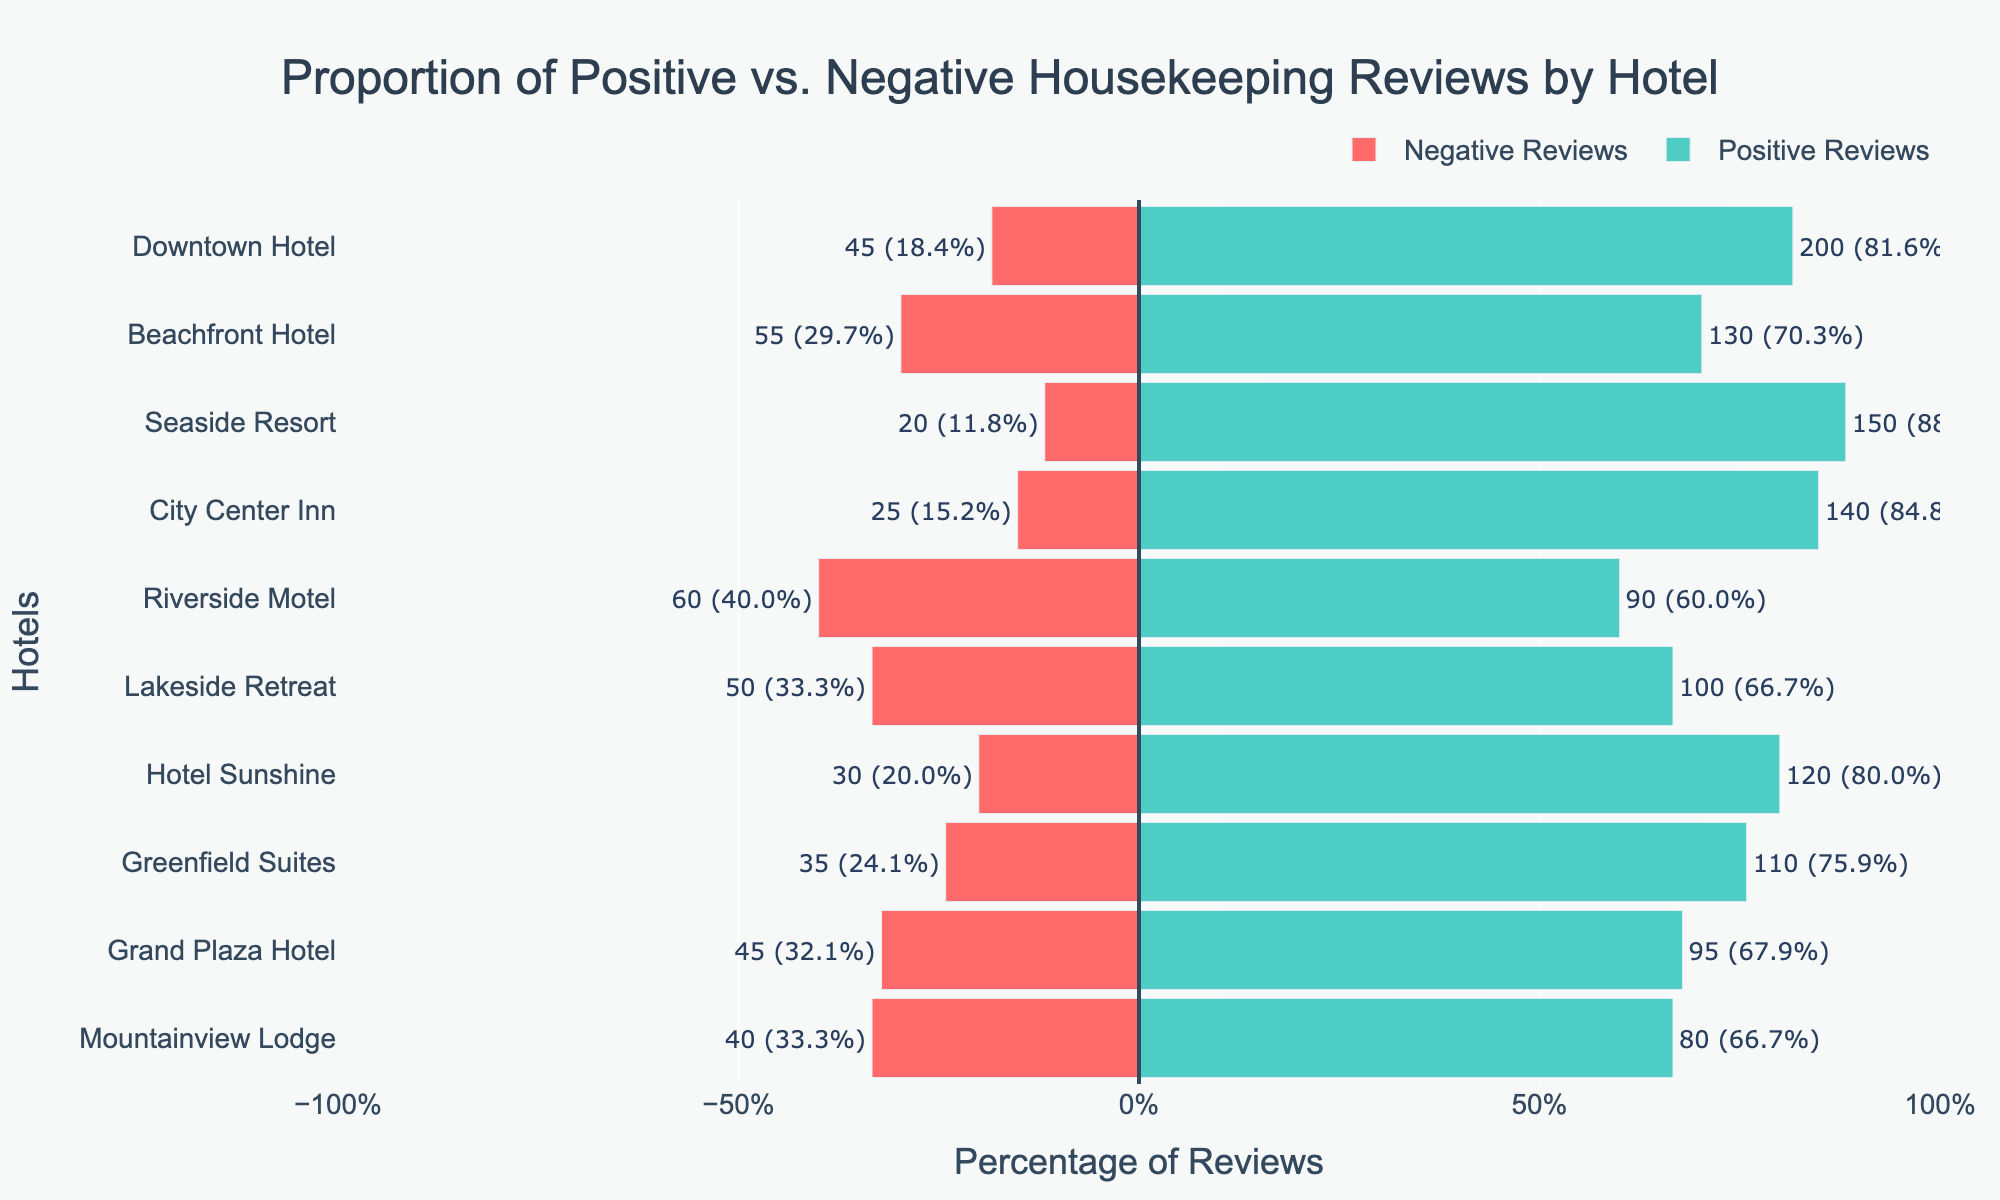What percentage of reviews for Hotel Sunshine are positive? To find the percentage of positive reviews for Hotel Sunshine, we refer to the length of the green bar representing positive reviews. The chart shows that Hotel Sunshine has around 80% positive reviews.
Answer: 80% Which hotel has the highest proportion of negative reviews? We compare the lengths of the red bars representing negative reviews. Riverside Motel has the longest red bar, indicating it has the highest proportion of negative reviews, around 40%.
Answer: Riverside Motel Compare the positive review percentages of City Center Inn and Downtown Hotel. Which one is higher? We look at the lengths of the green bars for both hotels. Downtown Hotel's positive review percentage is higher than City Center Inn's.
Answer: Downtown Hotel What is the difference in the number of positive reviews between Lakeside Retreat and Greenfield Suites? We subtract the number of positive reviews for Lakeside Retreat (100) from Greenfield Suites (110). The difference is 10.
Answer: 10 How many total reviews did Mountainview Lodge receive? Sum the positive and negative reviews for Mountainview Lodge. The hotel has 80 positive and 40 negative reviews, so the total is 120.
Answer: 120 Which hotel has the smallest proportion of positive reviews? We identify the hotel with the shortest green bar representing positive reviews. Riverside Motel has the smallest proportion of positive reviews at around 60%.
Answer: Riverside Motel Are there any hotels where the proportion of negative reviews is less than 20%? We look for hotels with a very short red bar. Seaside Resort has about 15% negative reviews, which is less than 20%.
Answer: Seaside Resort What is the combined percentage of positive reviews for Beachfront Hotel and Seaside Resort? Add the positive review percentages for both hotels. Beachfront Hotel has approximately 70% and Seaside Resort has 88%. The combined percentage is 158%.
Answer: 158% Which hotel has more negative reviews, Grand Plaza Hotel or Downtown Hotel? Compare the lengths of the red bars for both hotels. Grand Plaza Hotel has 45 negative reviews and Downtown Hotel also has 45. They are equal.
Answer: They are equal What is the average percentage of positive reviews for all hotels? Find the average by summing the positive percentages of all hotels and dividing by the number of hotels (10). (80 + 67.86 + 88.24 + 66.67 + 84.85 + 75.86 + 66.67 + 81.63 + 70.27 + 60) / 10 = 74.11%.
Answer: 74.11% 